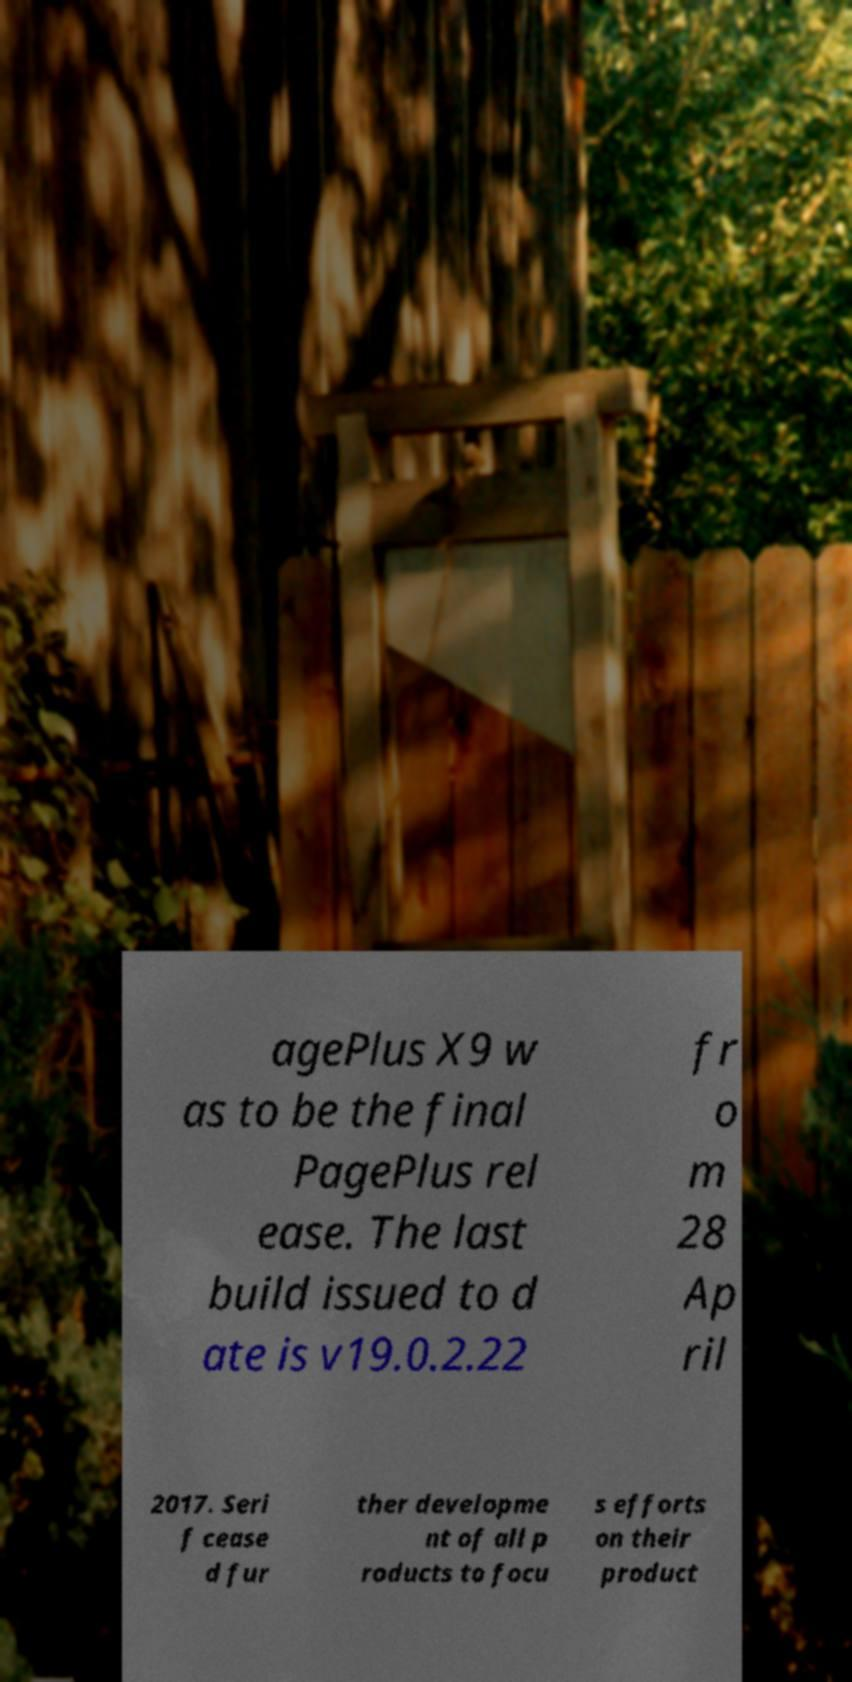Please read and relay the text visible in this image. What does it say? agePlus X9 w as to be the final PagePlus rel ease. The last build issued to d ate is v19.0.2.22 fr o m 28 Ap ril 2017. Seri f cease d fur ther developme nt of all p roducts to focu s efforts on their product 